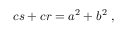<formula> <loc_0><loc_0><loc_500><loc_500>c s + c r = a ^ { 2 } + b ^ { 2 } \ ,</formula> 